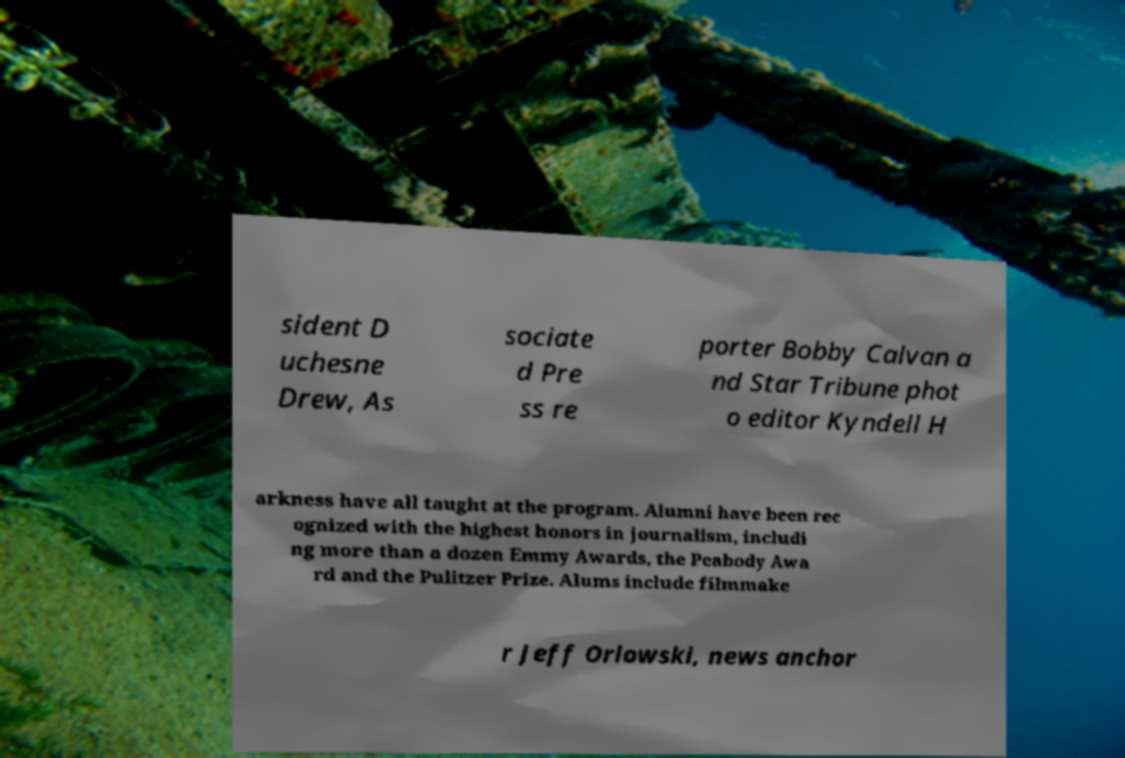Could you assist in decoding the text presented in this image and type it out clearly? sident D uchesne Drew, As sociate d Pre ss re porter Bobby Calvan a nd Star Tribune phot o editor Kyndell H arkness have all taught at the program. Alumni have been rec ognized with the highest honors in journalism, includi ng more than a dozen Emmy Awards, the Peabody Awa rd and the Pulitzer Prize. Alums include filmmake r Jeff Orlowski, news anchor 